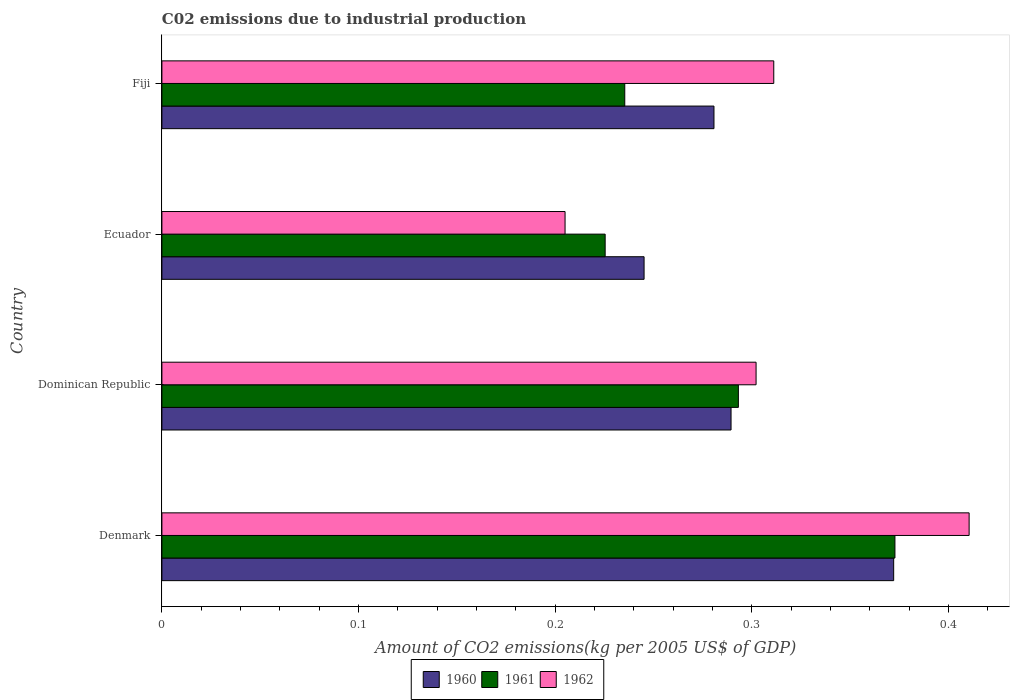How many groups of bars are there?
Offer a very short reply. 4. Are the number of bars on each tick of the Y-axis equal?
Offer a very short reply. Yes. What is the label of the 4th group of bars from the top?
Make the answer very short. Denmark. In how many cases, is the number of bars for a given country not equal to the number of legend labels?
Provide a succinct answer. 0. What is the amount of CO2 emitted due to industrial production in 1962 in Ecuador?
Give a very brief answer. 0.21. Across all countries, what is the maximum amount of CO2 emitted due to industrial production in 1962?
Keep it short and to the point. 0.41. Across all countries, what is the minimum amount of CO2 emitted due to industrial production in 1962?
Make the answer very short. 0.21. In which country was the amount of CO2 emitted due to industrial production in 1962 maximum?
Ensure brevity in your answer.  Denmark. In which country was the amount of CO2 emitted due to industrial production in 1961 minimum?
Keep it short and to the point. Ecuador. What is the total amount of CO2 emitted due to industrial production in 1962 in the graph?
Keep it short and to the point. 1.23. What is the difference between the amount of CO2 emitted due to industrial production in 1961 in Ecuador and that in Fiji?
Provide a short and direct response. -0.01. What is the difference between the amount of CO2 emitted due to industrial production in 1960 in Denmark and the amount of CO2 emitted due to industrial production in 1962 in Ecuador?
Ensure brevity in your answer.  0.17. What is the average amount of CO2 emitted due to industrial production in 1960 per country?
Keep it short and to the point. 0.3. What is the difference between the amount of CO2 emitted due to industrial production in 1960 and amount of CO2 emitted due to industrial production in 1962 in Fiji?
Your answer should be compact. -0.03. What is the ratio of the amount of CO2 emitted due to industrial production in 1961 in Denmark to that in Dominican Republic?
Provide a succinct answer. 1.27. What is the difference between the highest and the second highest amount of CO2 emitted due to industrial production in 1961?
Make the answer very short. 0.08. What is the difference between the highest and the lowest amount of CO2 emitted due to industrial production in 1960?
Provide a short and direct response. 0.13. In how many countries, is the amount of CO2 emitted due to industrial production in 1962 greater than the average amount of CO2 emitted due to industrial production in 1962 taken over all countries?
Offer a terse response. 2. What does the 3rd bar from the bottom in Dominican Republic represents?
Make the answer very short. 1962. Is it the case that in every country, the sum of the amount of CO2 emitted due to industrial production in 1960 and amount of CO2 emitted due to industrial production in 1962 is greater than the amount of CO2 emitted due to industrial production in 1961?
Your response must be concise. Yes. How many bars are there?
Your response must be concise. 12. How many countries are there in the graph?
Make the answer very short. 4. Are the values on the major ticks of X-axis written in scientific E-notation?
Offer a very short reply. No. Does the graph contain grids?
Offer a terse response. No. How many legend labels are there?
Give a very brief answer. 3. How are the legend labels stacked?
Provide a short and direct response. Horizontal. What is the title of the graph?
Your answer should be compact. C02 emissions due to industrial production. Does "2014" appear as one of the legend labels in the graph?
Your answer should be compact. No. What is the label or title of the X-axis?
Give a very brief answer. Amount of CO2 emissions(kg per 2005 US$ of GDP). What is the Amount of CO2 emissions(kg per 2005 US$ of GDP) in 1960 in Denmark?
Offer a terse response. 0.37. What is the Amount of CO2 emissions(kg per 2005 US$ of GDP) of 1961 in Denmark?
Provide a succinct answer. 0.37. What is the Amount of CO2 emissions(kg per 2005 US$ of GDP) in 1962 in Denmark?
Keep it short and to the point. 0.41. What is the Amount of CO2 emissions(kg per 2005 US$ of GDP) in 1960 in Dominican Republic?
Offer a terse response. 0.29. What is the Amount of CO2 emissions(kg per 2005 US$ of GDP) in 1961 in Dominican Republic?
Ensure brevity in your answer.  0.29. What is the Amount of CO2 emissions(kg per 2005 US$ of GDP) in 1962 in Dominican Republic?
Give a very brief answer. 0.3. What is the Amount of CO2 emissions(kg per 2005 US$ of GDP) in 1960 in Ecuador?
Provide a succinct answer. 0.25. What is the Amount of CO2 emissions(kg per 2005 US$ of GDP) in 1961 in Ecuador?
Offer a very short reply. 0.23. What is the Amount of CO2 emissions(kg per 2005 US$ of GDP) in 1962 in Ecuador?
Provide a succinct answer. 0.21. What is the Amount of CO2 emissions(kg per 2005 US$ of GDP) in 1960 in Fiji?
Give a very brief answer. 0.28. What is the Amount of CO2 emissions(kg per 2005 US$ of GDP) of 1961 in Fiji?
Your response must be concise. 0.24. What is the Amount of CO2 emissions(kg per 2005 US$ of GDP) of 1962 in Fiji?
Give a very brief answer. 0.31. Across all countries, what is the maximum Amount of CO2 emissions(kg per 2005 US$ of GDP) of 1960?
Give a very brief answer. 0.37. Across all countries, what is the maximum Amount of CO2 emissions(kg per 2005 US$ of GDP) in 1961?
Give a very brief answer. 0.37. Across all countries, what is the maximum Amount of CO2 emissions(kg per 2005 US$ of GDP) of 1962?
Provide a short and direct response. 0.41. Across all countries, what is the minimum Amount of CO2 emissions(kg per 2005 US$ of GDP) of 1960?
Provide a succinct answer. 0.25. Across all countries, what is the minimum Amount of CO2 emissions(kg per 2005 US$ of GDP) in 1961?
Make the answer very short. 0.23. Across all countries, what is the minimum Amount of CO2 emissions(kg per 2005 US$ of GDP) in 1962?
Your response must be concise. 0.21. What is the total Amount of CO2 emissions(kg per 2005 US$ of GDP) in 1960 in the graph?
Keep it short and to the point. 1.19. What is the total Amount of CO2 emissions(kg per 2005 US$ of GDP) of 1961 in the graph?
Your answer should be very brief. 1.13. What is the total Amount of CO2 emissions(kg per 2005 US$ of GDP) of 1962 in the graph?
Your answer should be very brief. 1.23. What is the difference between the Amount of CO2 emissions(kg per 2005 US$ of GDP) in 1960 in Denmark and that in Dominican Republic?
Your answer should be compact. 0.08. What is the difference between the Amount of CO2 emissions(kg per 2005 US$ of GDP) of 1961 in Denmark and that in Dominican Republic?
Your answer should be compact. 0.08. What is the difference between the Amount of CO2 emissions(kg per 2005 US$ of GDP) in 1962 in Denmark and that in Dominican Republic?
Keep it short and to the point. 0.11. What is the difference between the Amount of CO2 emissions(kg per 2005 US$ of GDP) in 1960 in Denmark and that in Ecuador?
Make the answer very short. 0.13. What is the difference between the Amount of CO2 emissions(kg per 2005 US$ of GDP) in 1961 in Denmark and that in Ecuador?
Make the answer very short. 0.15. What is the difference between the Amount of CO2 emissions(kg per 2005 US$ of GDP) in 1962 in Denmark and that in Ecuador?
Provide a succinct answer. 0.21. What is the difference between the Amount of CO2 emissions(kg per 2005 US$ of GDP) of 1960 in Denmark and that in Fiji?
Ensure brevity in your answer.  0.09. What is the difference between the Amount of CO2 emissions(kg per 2005 US$ of GDP) in 1961 in Denmark and that in Fiji?
Offer a terse response. 0.14. What is the difference between the Amount of CO2 emissions(kg per 2005 US$ of GDP) of 1962 in Denmark and that in Fiji?
Ensure brevity in your answer.  0.1. What is the difference between the Amount of CO2 emissions(kg per 2005 US$ of GDP) of 1960 in Dominican Republic and that in Ecuador?
Provide a short and direct response. 0.04. What is the difference between the Amount of CO2 emissions(kg per 2005 US$ of GDP) in 1961 in Dominican Republic and that in Ecuador?
Provide a succinct answer. 0.07. What is the difference between the Amount of CO2 emissions(kg per 2005 US$ of GDP) of 1962 in Dominican Republic and that in Ecuador?
Give a very brief answer. 0.1. What is the difference between the Amount of CO2 emissions(kg per 2005 US$ of GDP) in 1960 in Dominican Republic and that in Fiji?
Ensure brevity in your answer.  0.01. What is the difference between the Amount of CO2 emissions(kg per 2005 US$ of GDP) of 1961 in Dominican Republic and that in Fiji?
Your answer should be compact. 0.06. What is the difference between the Amount of CO2 emissions(kg per 2005 US$ of GDP) of 1962 in Dominican Republic and that in Fiji?
Your answer should be very brief. -0.01. What is the difference between the Amount of CO2 emissions(kg per 2005 US$ of GDP) of 1960 in Ecuador and that in Fiji?
Ensure brevity in your answer.  -0.04. What is the difference between the Amount of CO2 emissions(kg per 2005 US$ of GDP) in 1961 in Ecuador and that in Fiji?
Give a very brief answer. -0.01. What is the difference between the Amount of CO2 emissions(kg per 2005 US$ of GDP) in 1962 in Ecuador and that in Fiji?
Offer a terse response. -0.11. What is the difference between the Amount of CO2 emissions(kg per 2005 US$ of GDP) of 1960 in Denmark and the Amount of CO2 emissions(kg per 2005 US$ of GDP) of 1961 in Dominican Republic?
Make the answer very short. 0.08. What is the difference between the Amount of CO2 emissions(kg per 2005 US$ of GDP) of 1960 in Denmark and the Amount of CO2 emissions(kg per 2005 US$ of GDP) of 1962 in Dominican Republic?
Make the answer very short. 0.07. What is the difference between the Amount of CO2 emissions(kg per 2005 US$ of GDP) of 1961 in Denmark and the Amount of CO2 emissions(kg per 2005 US$ of GDP) of 1962 in Dominican Republic?
Give a very brief answer. 0.07. What is the difference between the Amount of CO2 emissions(kg per 2005 US$ of GDP) in 1960 in Denmark and the Amount of CO2 emissions(kg per 2005 US$ of GDP) in 1961 in Ecuador?
Offer a very short reply. 0.15. What is the difference between the Amount of CO2 emissions(kg per 2005 US$ of GDP) of 1960 in Denmark and the Amount of CO2 emissions(kg per 2005 US$ of GDP) of 1962 in Ecuador?
Provide a short and direct response. 0.17. What is the difference between the Amount of CO2 emissions(kg per 2005 US$ of GDP) of 1961 in Denmark and the Amount of CO2 emissions(kg per 2005 US$ of GDP) of 1962 in Ecuador?
Make the answer very short. 0.17. What is the difference between the Amount of CO2 emissions(kg per 2005 US$ of GDP) in 1960 in Denmark and the Amount of CO2 emissions(kg per 2005 US$ of GDP) in 1961 in Fiji?
Ensure brevity in your answer.  0.14. What is the difference between the Amount of CO2 emissions(kg per 2005 US$ of GDP) of 1960 in Denmark and the Amount of CO2 emissions(kg per 2005 US$ of GDP) of 1962 in Fiji?
Give a very brief answer. 0.06. What is the difference between the Amount of CO2 emissions(kg per 2005 US$ of GDP) in 1961 in Denmark and the Amount of CO2 emissions(kg per 2005 US$ of GDP) in 1962 in Fiji?
Your answer should be very brief. 0.06. What is the difference between the Amount of CO2 emissions(kg per 2005 US$ of GDP) in 1960 in Dominican Republic and the Amount of CO2 emissions(kg per 2005 US$ of GDP) in 1961 in Ecuador?
Provide a short and direct response. 0.06. What is the difference between the Amount of CO2 emissions(kg per 2005 US$ of GDP) of 1960 in Dominican Republic and the Amount of CO2 emissions(kg per 2005 US$ of GDP) of 1962 in Ecuador?
Keep it short and to the point. 0.08. What is the difference between the Amount of CO2 emissions(kg per 2005 US$ of GDP) in 1961 in Dominican Republic and the Amount of CO2 emissions(kg per 2005 US$ of GDP) in 1962 in Ecuador?
Offer a very short reply. 0.09. What is the difference between the Amount of CO2 emissions(kg per 2005 US$ of GDP) of 1960 in Dominican Republic and the Amount of CO2 emissions(kg per 2005 US$ of GDP) of 1961 in Fiji?
Give a very brief answer. 0.05. What is the difference between the Amount of CO2 emissions(kg per 2005 US$ of GDP) in 1960 in Dominican Republic and the Amount of CO2 emissions(kg per 2005 US$ of GDP) in 1962 in Fiji?
Ensure brevity in your answer.  -0.02. What is the difference between the Amount of CO2 emissions(kg per 2005 US$ of GDP) of 1961 in Dominican Republic and the Amount of CO2 emissions(kg per 2005 US$ of GDP) of 1962 in Fiji?
Your answer should be compact. -0.02. What is the difference between the Amount of CO2 emissions(kg per 2005 US$ of GDP) in 1960 in Ecuador and the Amount of CO2 emissions(kg per 2005 US$ of GDP) in 1961 in Fiji?
Provide a short and direct response. 0.01. What is the difference between the Amount of CO2 emissions(kg per 2005 US$ of GDP) of 1960 in Ecuador and the Amount of CO2 emissions(kg per 2005 US$ of GDP) of 1962 in Fiji?
Give a very brief answer. -0.07. What is the difference between the Amount of CO2 emissions(kg per 2005 US$ of GDP) in 1961 in Ecuador and the Amount of CO2 emissions(kg per 2005 US$ of GDP) in 1962 in Fiji?
Ensure brevity in your answer.  -0.09. What is the average Amount of CO2 emissions(kg per 2005 US$ of GDP) of 1960 per country?
Ensure brevity in your answer.  0.3. What is the average Amount of CO2 emissions(kg per 2005 US$ of GDP) in 1961 per country?
Ensure brevity in your answer.  0.28. What is the average Amount of CO2 emissions(kg per 2005 US$ of GDP) of 1962 per country?
Your response must be concise. 0.31. What is the difference between the Amount of CO2 emissions(kg per 2005 US$ of GDP) of 1960 and Amount of CO2 emissions(kg per 2005 US$ of GDP) of 1961 in Denmark?
Give a very brief answer. -0. What is the difference between the Amount of CO2 emissions(kg per 2005 US$ of GDP) of 1960 and Amount of CO2 emissions(kg per 2005 US$ of GDP) of 1962 in Denmark?
Your response must be concise. -0.04. What is the difference between the Amount of CO2 emissions(kg per 2005 US$ of GDP) of 1961 and Amount of CO2 emissions(kg per 2005 US$ of GDP) of 1962 in Denmark?
Offer a terse response. -0.04. What is the difference between the Amount of CO2 emissions(kg per 2005 US$ of GDP) in 1960 and Amount of CO2 emissions(kg per 2005 US$ of GDP) in 1961 in Dominican Republic?
Your answer should be compact. -0. What is the difference between the Amount of CO2 emissions(kg per 2005 US$ of GDP) of 1960 and Amount of CO2 emissions(kg per 2005 US$ of GDP) of 1962 in Dominican Republic?
Ensure brevity in your answer.  -0.01. What is the difference between the Amount of CO2 emissions(kg per 2005 US$ of GDP) in 1961 and Amount of CO2 emissions(kg per 2005 US$ of GDP) in 1962 in Dominican Republic?
Give a very brief answer. -0.01. What is the difference between the Amount of CO2 emissions(kg per 2005 US$ of GDP) in 1960 and Amount of CO2 emissions(kg per 2005 US$ of GDP) in 1961 in Ecuador?
Offer a very short reply. 0.02. What is the difference between the Amount of CO2 emissions(kg per 2005 US$ of GDP) in 1960 and Amount of CO2 emissions(kg per 2005 US$ of GDP) in 1962 in Ecuador?
Your answer should be very brief. 0.04. What is the difference between the Amount of CO2 emissions(kg per 2005 US$ of GDP) of 1961 and Amount of CO2 emissions(kg per 2005 US$ of GDP) of 1962 in Ecuador?
Your response must be concise. 0.02. What is the difference between the Amount of CO2 emissions(kg per 2005 US$ of GDP) of 1960 and Amount of CO2 emissions(kg per 2005 US$ of GDP) of 1961 in Fiji?
Ensure brevity in your answer.  0.05. What is the difference between the Amount of CO2 emissions(kg per 2005 US$ of GDP) of 1960 and Amount of CO2 emissions(kg per 2005 US$ of GDP) of 1962 in Fiji?
Ensure brevity in your answer.  -0.03. What is the difference between the Amount of CO2 emissions(kg per 2005 US$ of GDP) in 1961 and Amount of CO2 emissions(kg per 2005 US$ of GDP) in 1962 in Fiji?
Offer a very short reply. -0.08. What is the ratio of the Amount of CO2 emissions(kg per 2005 US$ of GDP) of 1960 in Denmark to that in Dominican Republic?
Make the answer very short. 1.29. What is the ratio of the Amount of CO2 emissions(kg per 2005 US$ of GDP) of 1961 in Denmark to that in Dominican Republic?
Offer a very short reply. 1.27. What is the ratio of the Amount of CO2 emissions(kg per 2005 US$ of GDP) in 1962 in Denmark to that in Dominican Republic?
Give a very brief answer. 1.36. What is the ratio of the Amount of CO2 emissions(kg per 2005 US$ of GDP) of 1960 in Denmark to that in Ecuador?
Your answer should be compact. 1.52. What is the ratio of the Amount of CO2 emissions(kg per 2005 US$ of GDP) of 1961 in Denmark to that in Ecuador?
Your answer should be very brief. 1.65. What is the ratio of the Amount of CO2 emissions(kg per 2005 US$ of GDP) in 1962 in Denmark to that in Ecuador?
Provide a succinct answer. 2. What is the ratio of the Amount of CO2 emissions(kg per 2005 US$ of GDP) of 1960 in Denmark to that in Fiji?
Provide a succinct answer. 1.33. What is the ratio of the Amount of CO2 emissions(kg per 2005 US$ of GDP) of 1961 in Denmark to that in Fiji?
Make the answer very short. 1.58. What is the ratio of the Amount of CO2 emissions(kg per 2005 US$ of GDP) in 1962 in Denmark to that in Fiji?
Offer a very short reply. 1.32. What is the ratio of the Amount of CO2 emissions(kg per 2005 US$ of GDP) of 1960 in Dominican Republic to that in Ecuador?
Provide a short and direct response. 1.18. What is the ratio of the Amount of CO2 emissions(kg per 2005 US$ of GDP) of 1961 in Dominican Republic to that in Ecuador?
Keep it short and to the point. 1.3. What is the ratio of the Amount of CO2 emissions(kg per 2005 US$ of GDP) of 1962 in Dominican Republic to that in Ecuador?
Provide a succinct answer. 1.47. What is the ratio of the Amount of CO2 emissions(kg per 2005 US$ of GDP) in 1960 in Dominican Republic to that in Fiji?
Ensure brevity in your answer.  1.03. What is the ratio of the Amount of CO2 emissions(kg per 2005 US$ of GDP) in 1961 in Dominican Republic to that in Fiji?
Provide a succinct answer. 1.25. What is the ratio of the Amount of CO2 emissions(kg per 2005 US$ of GDP) in 1962 in Dominican Republic to that in Fiji?
Give a very brief answer. 0.97. What is the ratio of the Amount of CO2 emissions(kg per 2005 US$ of GDP) in 1960 in Ecuador to that in Fiji?
Provide a succinct answer. 0.87. What is the ratio of the Amount of CO2 emissions(kg per 2005 US$ of GDP) in 1961 in Ecuador to that in Fiji?
Offer a terse response. 0.96. What is the ratio of the Amount of CO2 emissions(kg per 2005 US$ of GDP) of 1962 in Ecuador to that in Fiji?
Provide a short and direct response. 0.66. What is the difference between the highest and the second highest Amount of CO2 emissions(kg per 2005 US$ of GDP) in 1960?
Your response must be concise. 0.08. What is the difference between the highest and the second highest Amount of CO2 emissions(kg per 2005 US$ of GDP) of 1961?
Your response must be concise. 0.08. What is the difference between the highest and the second highest Amount of CO2 emissions(kg per 2005 US$ of GDP) in 1962?
Provide a succinct answer. 0.1. What is the difference between the highest and the lowest Amount of CO2 emissions(kg per 2005 US$ of GDP) in 1960?
Make the answer very short. 0.13. What is the difference between the highest and the lowest Amount of CO2 emissions(kg per 2005 US$ of GDP) in 1961?
Give a very brief answer. 0.15. What is the difference between the highest and the lowest Amount of CO2 emissions(kg per 2005 US$ of GDP) in 1962?
Your answer should be compact. 0.21. 